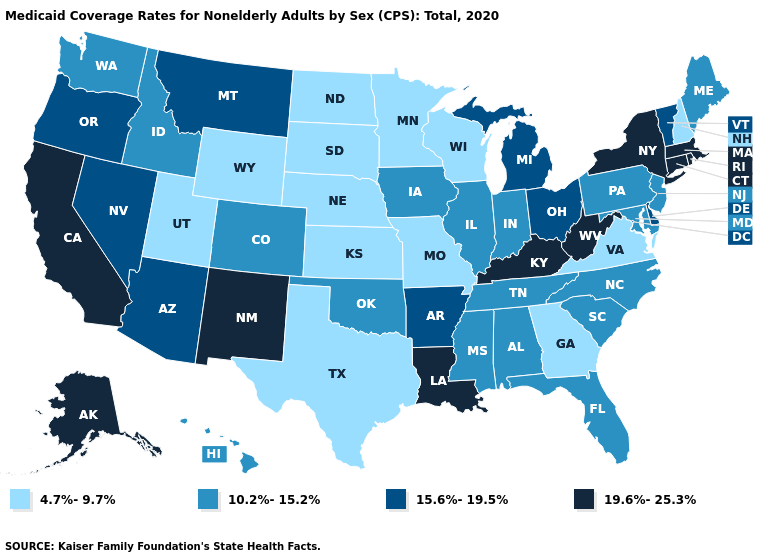Is the legend a continuous bar?
Write a very short answer. No. What is the highest value in the Northeast ?
Be succinct. 19.6%-25.3%. What is the value of Rhode Island?
Short answer required. 19.6%-25.3%. Among the states that border Kansas , which have the highest value?
Concise answer only. Colorado, Oklahoma. What is the value of West Virginia?
Concise answer only. 19.6%-25.3%. Does Connecticut have the highest value in the USA?
Keep it brief. Yes. Name the states that have a value in the range 10.2%-15.2%?
Answer briefly. Alabama, Colorado, Florida, Hawaii, Idaho, Illinois, Indiana, Iowa, Maine, Maryland, Mississippi, New Jersey, North Carolina, Oklahoma, Pennsylvania, South Carolina, Tennessee, Washington. Does North Dakota have the lowest value in the MidWest?
Answer briefly. Yes. Does Ohio have the highest value in the MidWest?
Answer briefly. Yes. Does Louisiana have the highest value in the South?
Short answer required. Yes. Does the map have missing data?
Give a very brief answer. No. What is the highest value in the Northeast ?
Short answer required. 19.6%-25.3%. Does North Dakota have the lowest value in the USA?
Write a very short answer. Yes. Among the states that border Idaho , does Nevada have the lowest value?
Concise answer only. No. Is the legend a continuous bar?
Write a very short answer. No. 